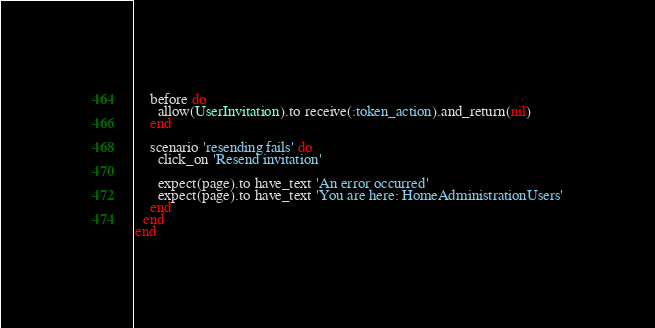<code> <loc_0><loc_0><loc_500><loc_500><_Ruby_>    before do
      allow(UserInvitation).to receive(:token_action).and_return(nil)
    end

    scenario 'resending fails' do
      click_on 'Resend invitation'

      expect(page).to have_text 'An error occurred'
      expect(page).to have_text 'You are here: HomeAdministrationUsers'
    end
  end
end
</code> 